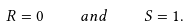<formula> <loc_0><loc_0><loc_500><loc_500>R = 0 \quad a n d \quad S = 1 .</formula> 